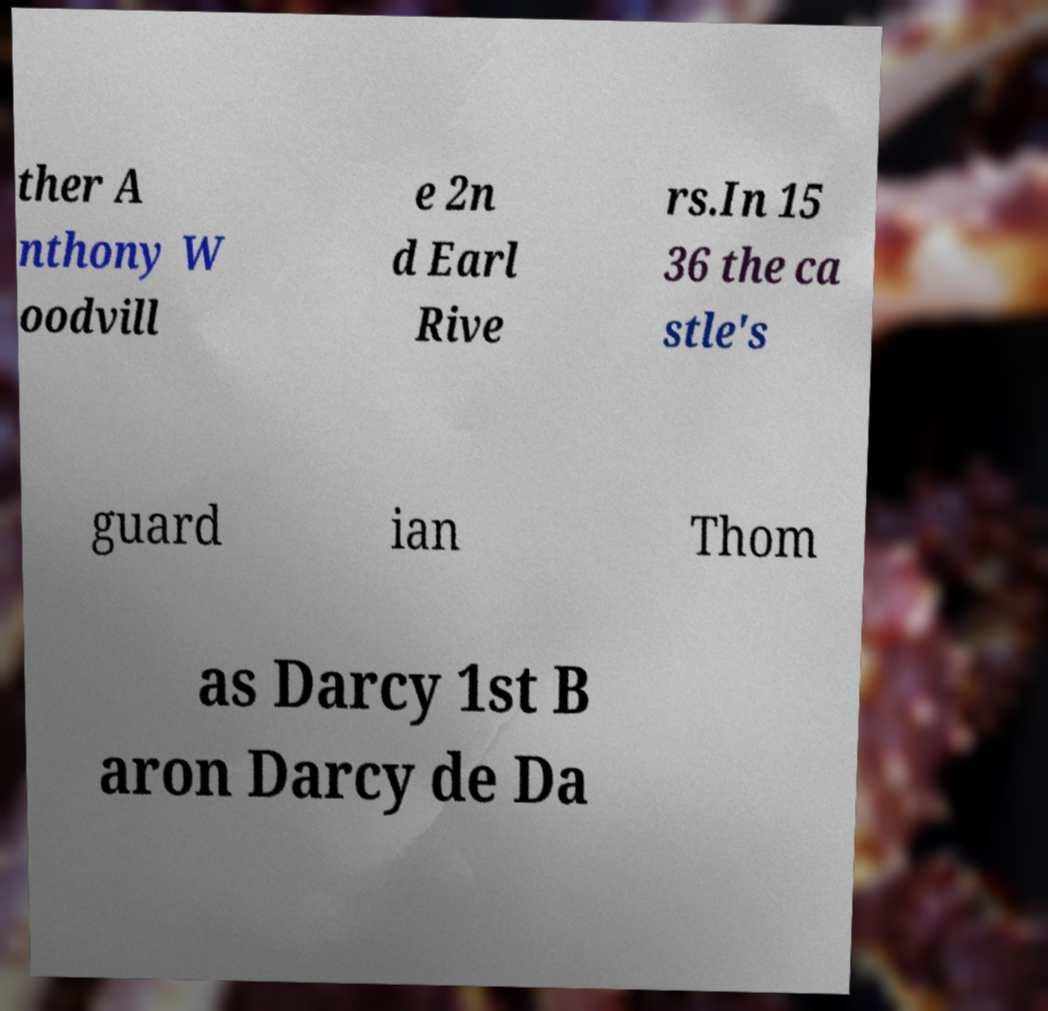There's text embedded in this image that I need extracted. Can you transcribe it verbatim? ther A nthony W oodvill e 2n d Earl Rive rs.In 15 36 the ca stle's guard ian Thom as Darcy 1st B aron Darcy de Da 